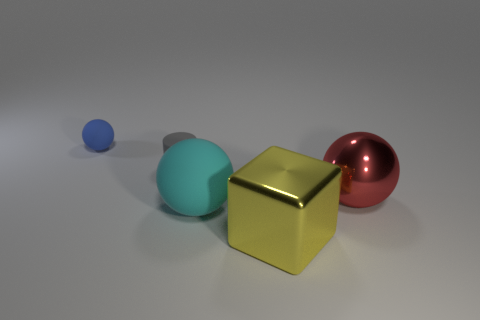How many other objects are there of the same material as the cyan ball?
Your response must be concise. 2. Are there more big red spheres that are left of the small rubber ball than big metal blocks that are behind the red shiny object?
Your response must be concise. No. What number of small objects are on the left side of the gray matte thing?
Offer a terse response. 1. Are the small ball and the large object on the right side of the big yellow metal block made of the same material?
Give a very brief answer. No. Is there any other thing that is the same shape as the red shiny thing?
Offer a terse response. Yes. Do the big red sphere and the big cyan thing have the same material?
Offer a very short reply. No. Is there a small rubber thing that is behind the big metal object that is behind the large matte ball?
Your answer should be compact. Yes. What number of things are both to the right of the small matte ball and behind the yellow cube?
Your answer should be very brief. 3. There is a thing to the right of the yellow shiny cube; what is its shape?
Your response must be concise. Sphere. How many rubber objects are the same size as the blue sphere?
Provide a short and direct response. 1. 